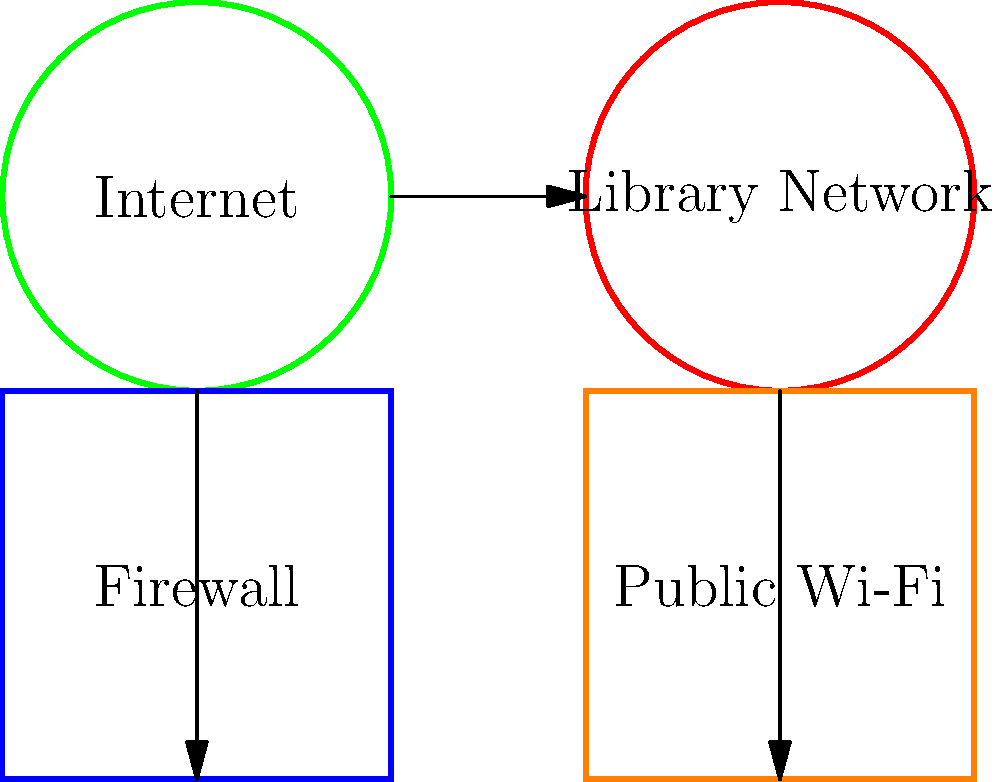In the given network diagram for the library's public Wi-Fi security setup, which component should be placed between the Internet and the Library Network to enhance security? To design a basic firewall configuration for securing the library's public Wi-Fi network, we need to follow these steps:

1. Identify the network components:
   - Internet (external network)
   - Library Network (internal network)
   - Public Wi-Fi (part of the internal network)
   - Firewall (security component)

2. Understand the purpose of a firewall:
   - A firewall acts as a barrier between trusted internal networks and untrusted external networks (like the Internet).
   - It monitors and controls incoming and outgoing network traffic based on predetermined security rules.

3. Determine the correct placement of the firewall:
   - The firewall should be positioned between the Internet and the Library Network.
   - This placement allows the firewall to inspect all traffic entering and leaving the library's network, including the public Wi-Fi.

4. Configure the firewall:
   - Set up rules to allow necessary traffic and block potential threats.
   - Implement Network Address Translation (NAT) to hide internal IP addresses.
   - Enable logging for security monitoring and analysis.

5. Secure the public Wi-Fi:
   - Isolate the public Wi-Fi from the main library network.
   - Use WPA2 encryption for the Wi-Fi connection.
   - Implement a captive portal for user authentication.

In the diagram, the firewall is represented by the blue box between the Internet (green circle) and the Library Network (red circle). This placement ensures that all traffic, including that from the public Wi-Fi (orange box), passes through the firewall for inspection and filtering.
Answer: Firewall 